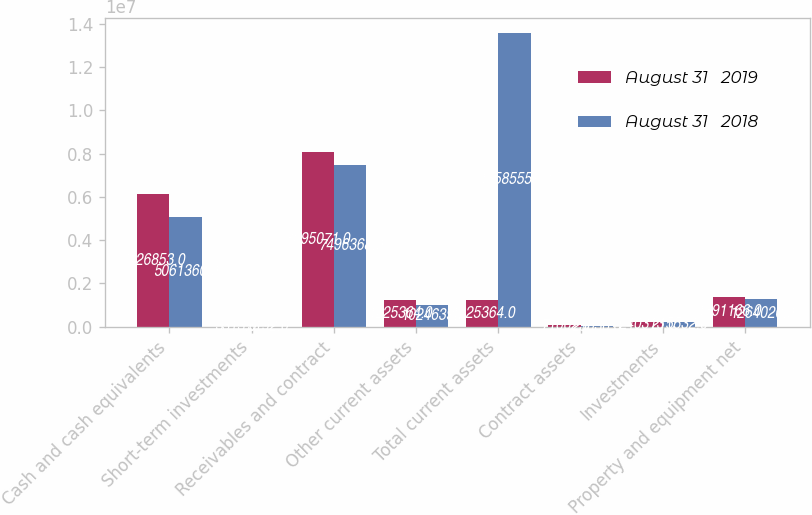<chart> <loc_0><loc_0><loc_500><loc_500><stacked_bar_chart><ecel><fcel>Cash and cash equivalents<fcel>Short-term investments<fcel>Receivables and contract<fcel>Other current assets<fcel>Total current assets<fcel>Contract assets<fcel>Investments<fcel>Property and equipment net<nl><fcel>August 31   2019<fcel>6.12685e+06<fcel>3313<fcel>8.09507e+06<fcel>1.22536e+06<fcel>1.22536e+06<fcel>71002<fcel>240313<fcel>1.39117e+06<nl><fcel>August 31   2018<fcel>5.06136e+06<fcel>3192<fcel>7.49637e+06<fcel>1.02464e+06<fcel>1.35856e+07<fcel>23036<fcel>215532<fcel>1.26402e+06<nl></chart> 